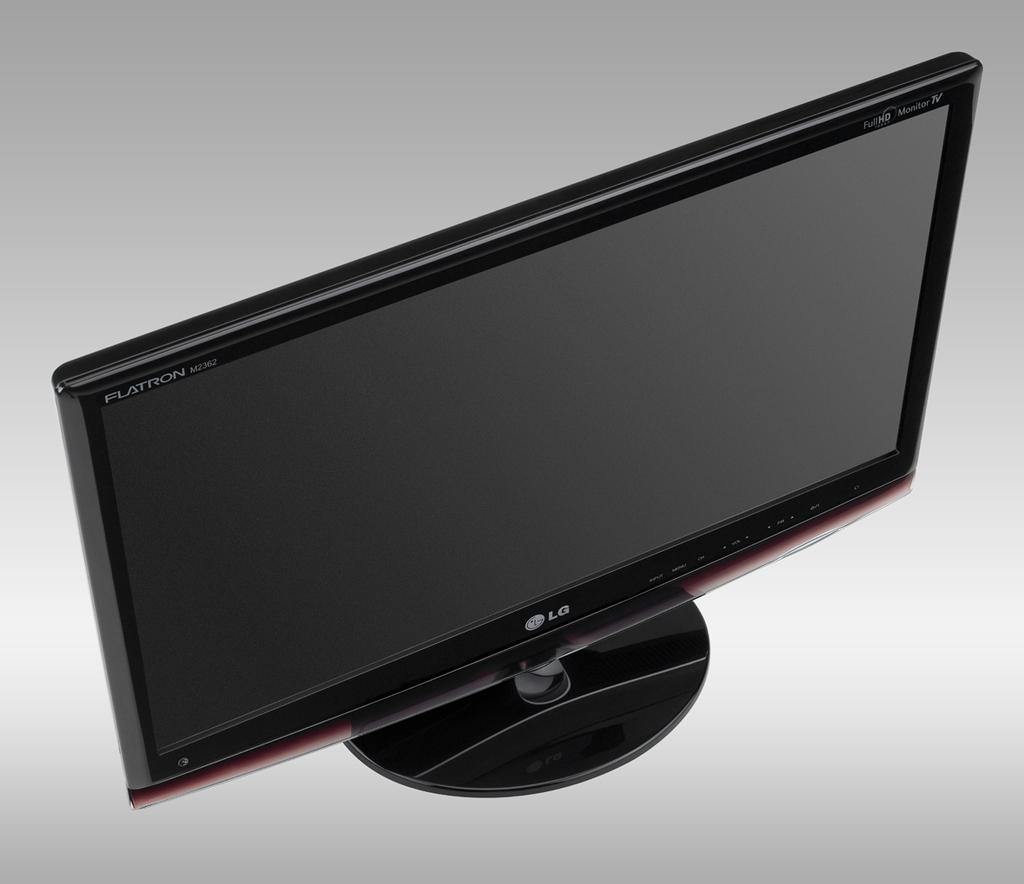<image>
Summarize the visual content of the image. Bird's eye view of a LG monitor with Flat iron written in the upper right corner of monitor. 